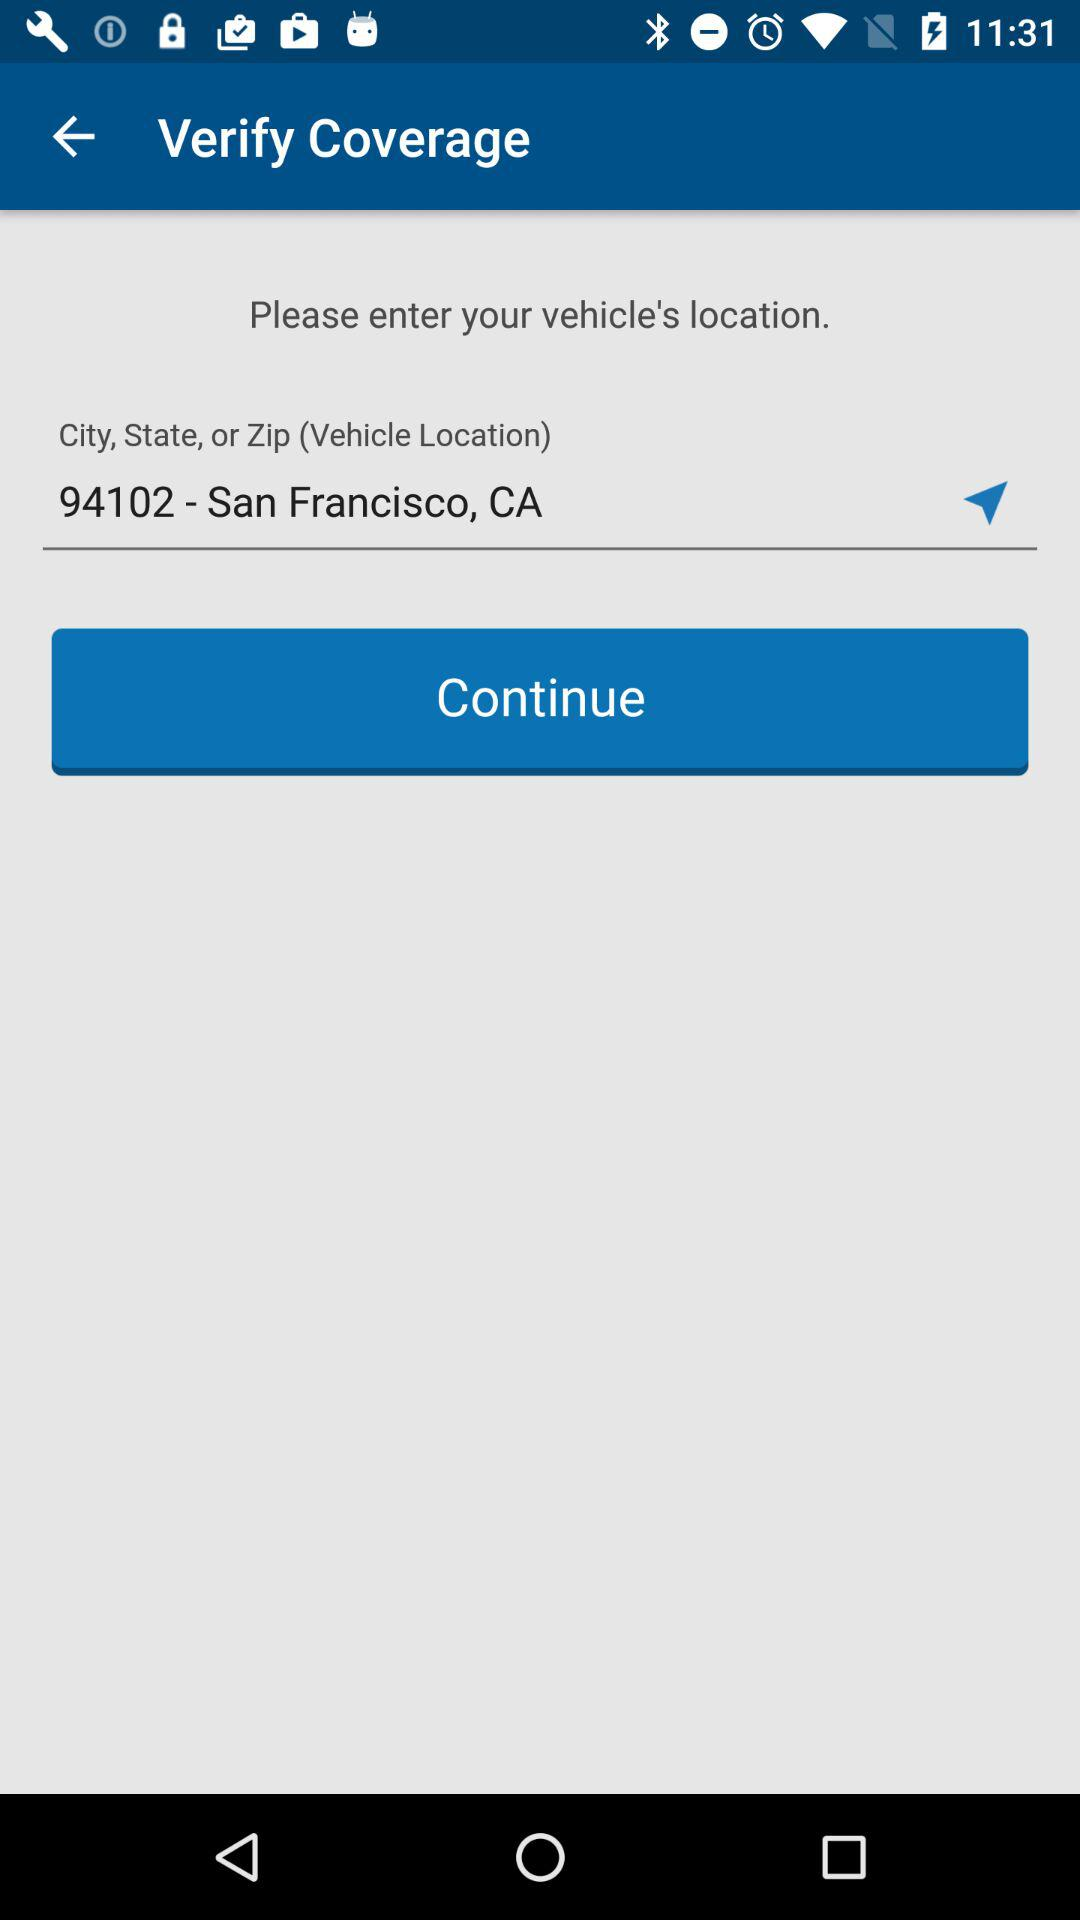What is the vehicle's location? The vehicle's location is San Francisco, CA, 94102. 